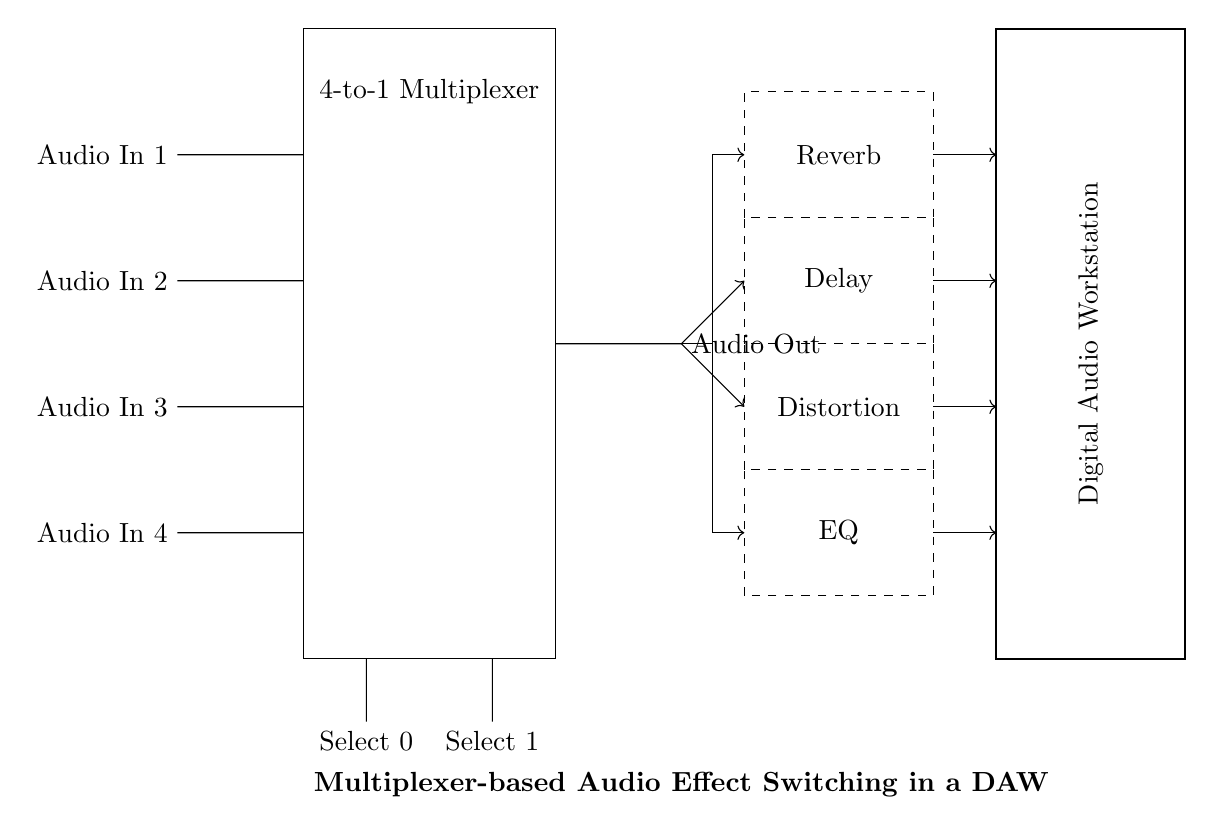What is the main function of the circuit? The circuit is designed to switch between multiple audio effects in a digital audio workstation using a multiplexer.
Answer: Switching audio effects How many audio inputs does the circuit accept? The circuit has four distinct audio inputs.
Answer: Four What type of multiplexer is used in this circuit? The circuit uses a 4-to-1 multiplexer, which selects one of four inputs based on two control signals.
Answer: Four-to-one What are the control signals labeled in the circuit? The control signals are labeled as Select 0 and Select 1, determining which audio input is routed to the output.
Answer: Select 0 and Select 1 Which audio effect is at the top of the effects section? The top audio effect in the effects section is Reverb.
Answer: Reverb If Select 0 is high and Select 1 is low, which audio input is outputted? With Select 0 high and Select 1 low, input 1 is selected and passed to the output.
Answer: Audio In 1 How are audio effects connected to the multiplexer output? The output from the multiplexer is routed to four distinct audio effect blocks through direct connections.
Answer: Direct connections 